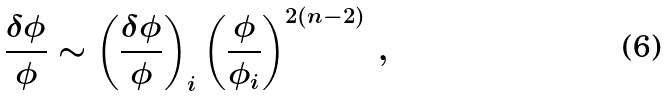<formula> <loc_0><loc_0><loc_500><loc_500>\frac { \delta \phi } { \phi } \sim \left ( \frac { \delta \phi } { \phi } \right ) _ { i } \left ( \frac { \phi } { \phi _ { i } } \right ) ^ { 2 ( n - 2 ) } \, ,</formula> 